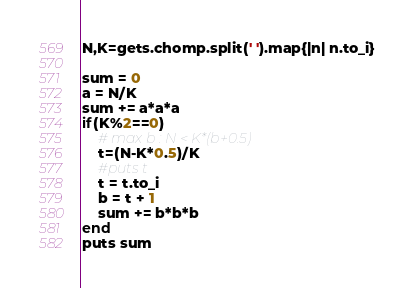Convert code to text. <code><loc_0><loc_0><loc_500><loc_500><_Ruby_>N,K=gets.chomp.split(' ').map{|n| n.to_i}

sum = 0
a = N/K
sum += a*a*a
if(K%2==0)
	# max b : N < K*(b+0.5)
	t=(N-K*0.5)/K
	#puts t
	t = t.to_i
	b = t + 1
	sum += b*b*b
end
puts sum


</code> 